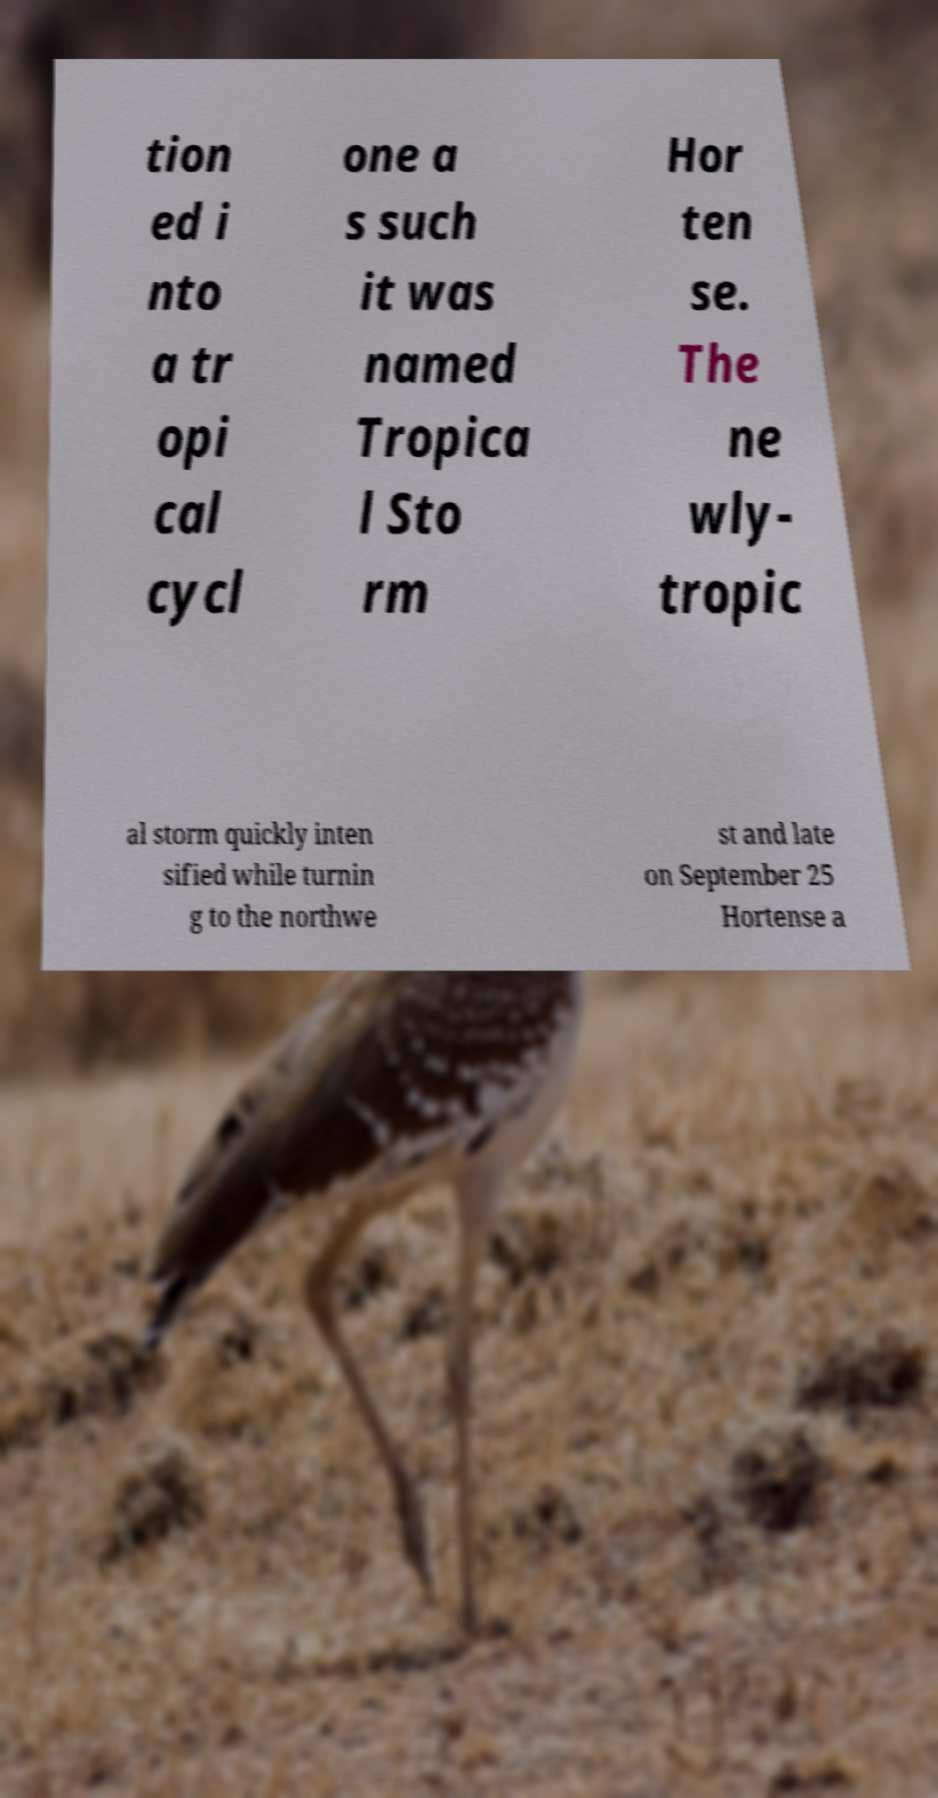I need the written content from this picture converted into text. Can you do that? tion ed i nto a tr opi cal cycl one a s such it was named Tropica l Sto rm Hor ten se. The ne wly- tropic al storm quickly inten sified while turnin g to the northwe st and late on September 25 Hortense a 